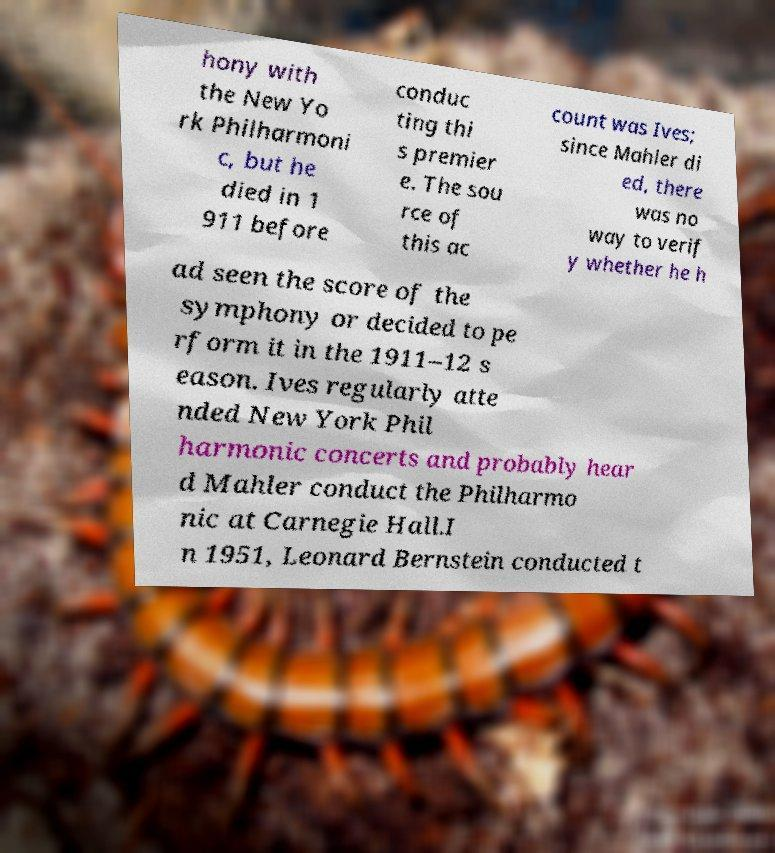Could you extract and type out the text from this image? hony with the New Yo rk Philharmoni c, but he died in 1 911 before conduc ting thi s premier e. The sou rce of this ac count was Ives; since Mahler di ed, there was no way to verif y whether he h ad seen the score of the symphony or decided to pe rform it in the 1911–12 s eason. Ives regularly atte nded New York Phil harmonic concerts and probably hear d Mahler conduct the Philharmo nic at Carnegie Hall.I n 1951, Leonard Bernstein conducted t 